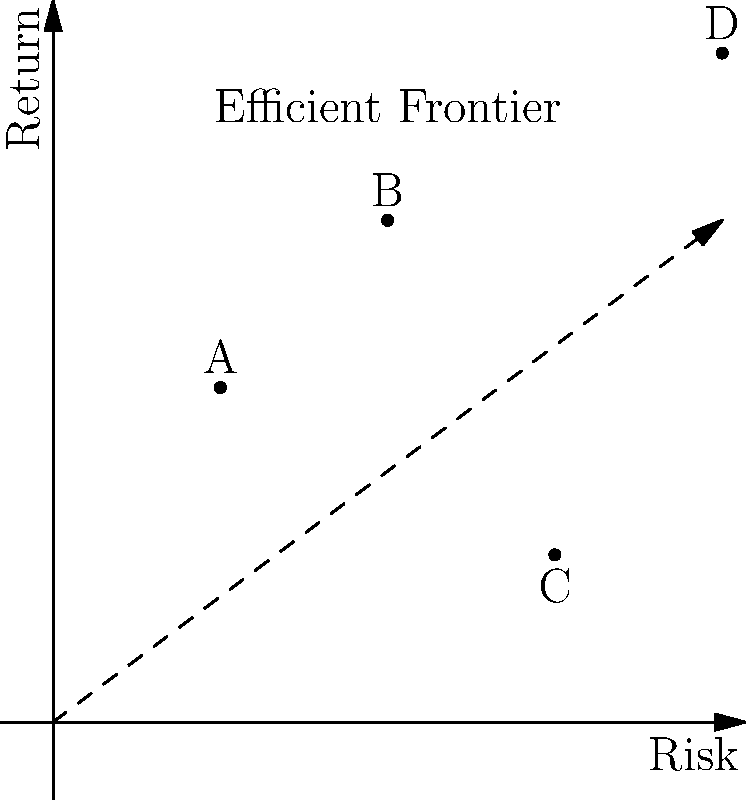In the given coordinate system representing portfolio risk and return, four assets (A, B, C, and D) are plotted. The dashed arrow represents the efficient frontier. If you're constructing a portfolio using only assets A and D, what would be the vector coordinates of a portfolio consisting of 60% asset A and 40% asset D? Express your answer as (risk, return). To solve this problem, we need to follow these steps:

1. Identify the coordinates of assets A and D:
   Asset A: (1, 2)
   Asset D: (4, 4)

2. Calculate the weighted average of the coordinates based on the portfolio allocation:
   60% of A and 40% of D

3. For the risk coordinate (x-axis):
   $x = 0.6 \times 1 + 0.4 \times 4 = 0.6 + 1.6 = 2.2$

4. For the return coordinate (y-axis):
   $y = 0.6 \times 2 + 0.4 \times 4 = 1.2 + 1.6 = 2.8$

5. Combine the calculated coordinates into a vector:
   (2.2, 2.8)

This vector represents the risk-return profile of the portfolio with 60% invested in asset A and 40% in asset D.
Answer: (2.2, 2.8) 